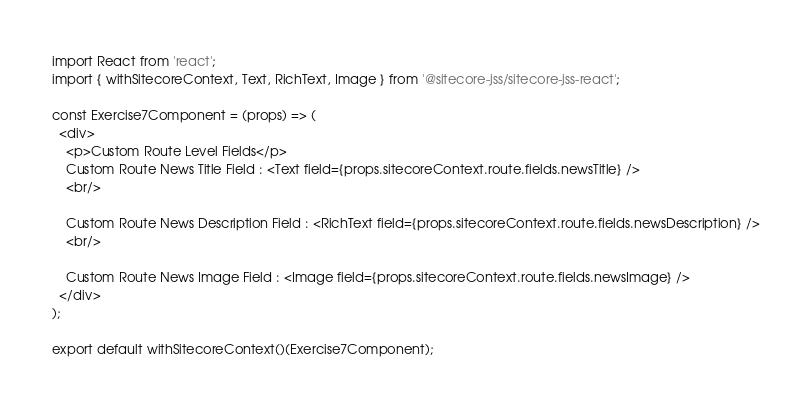<code> <loc_0><loc_0><loc_500><loc_500><_JavaScript_>import React from 'react';
import { withSitecoreContext, Text, RichText, Image } from '@sitecore-jss/sitecore-jss-react';

const Exercise7Component = (props) => (
  <div>
    <p>Custom Route Level Fields</p>
    Custom Route News Title Field : <Text field={props.sitecoreContext.route.fields.newsTitle} />
    <br/>

    Custom Route News Description Field : <RichText field={props.sitecoreContext.route.fields.newsDescription} />
    <br/>

    Custom Route News Image Field : <Image field={props.sitecoreContext.route.fields.newsImage} />
  </div>
);

export default withSitecoreContext()(Exercise7Component);
</code> 